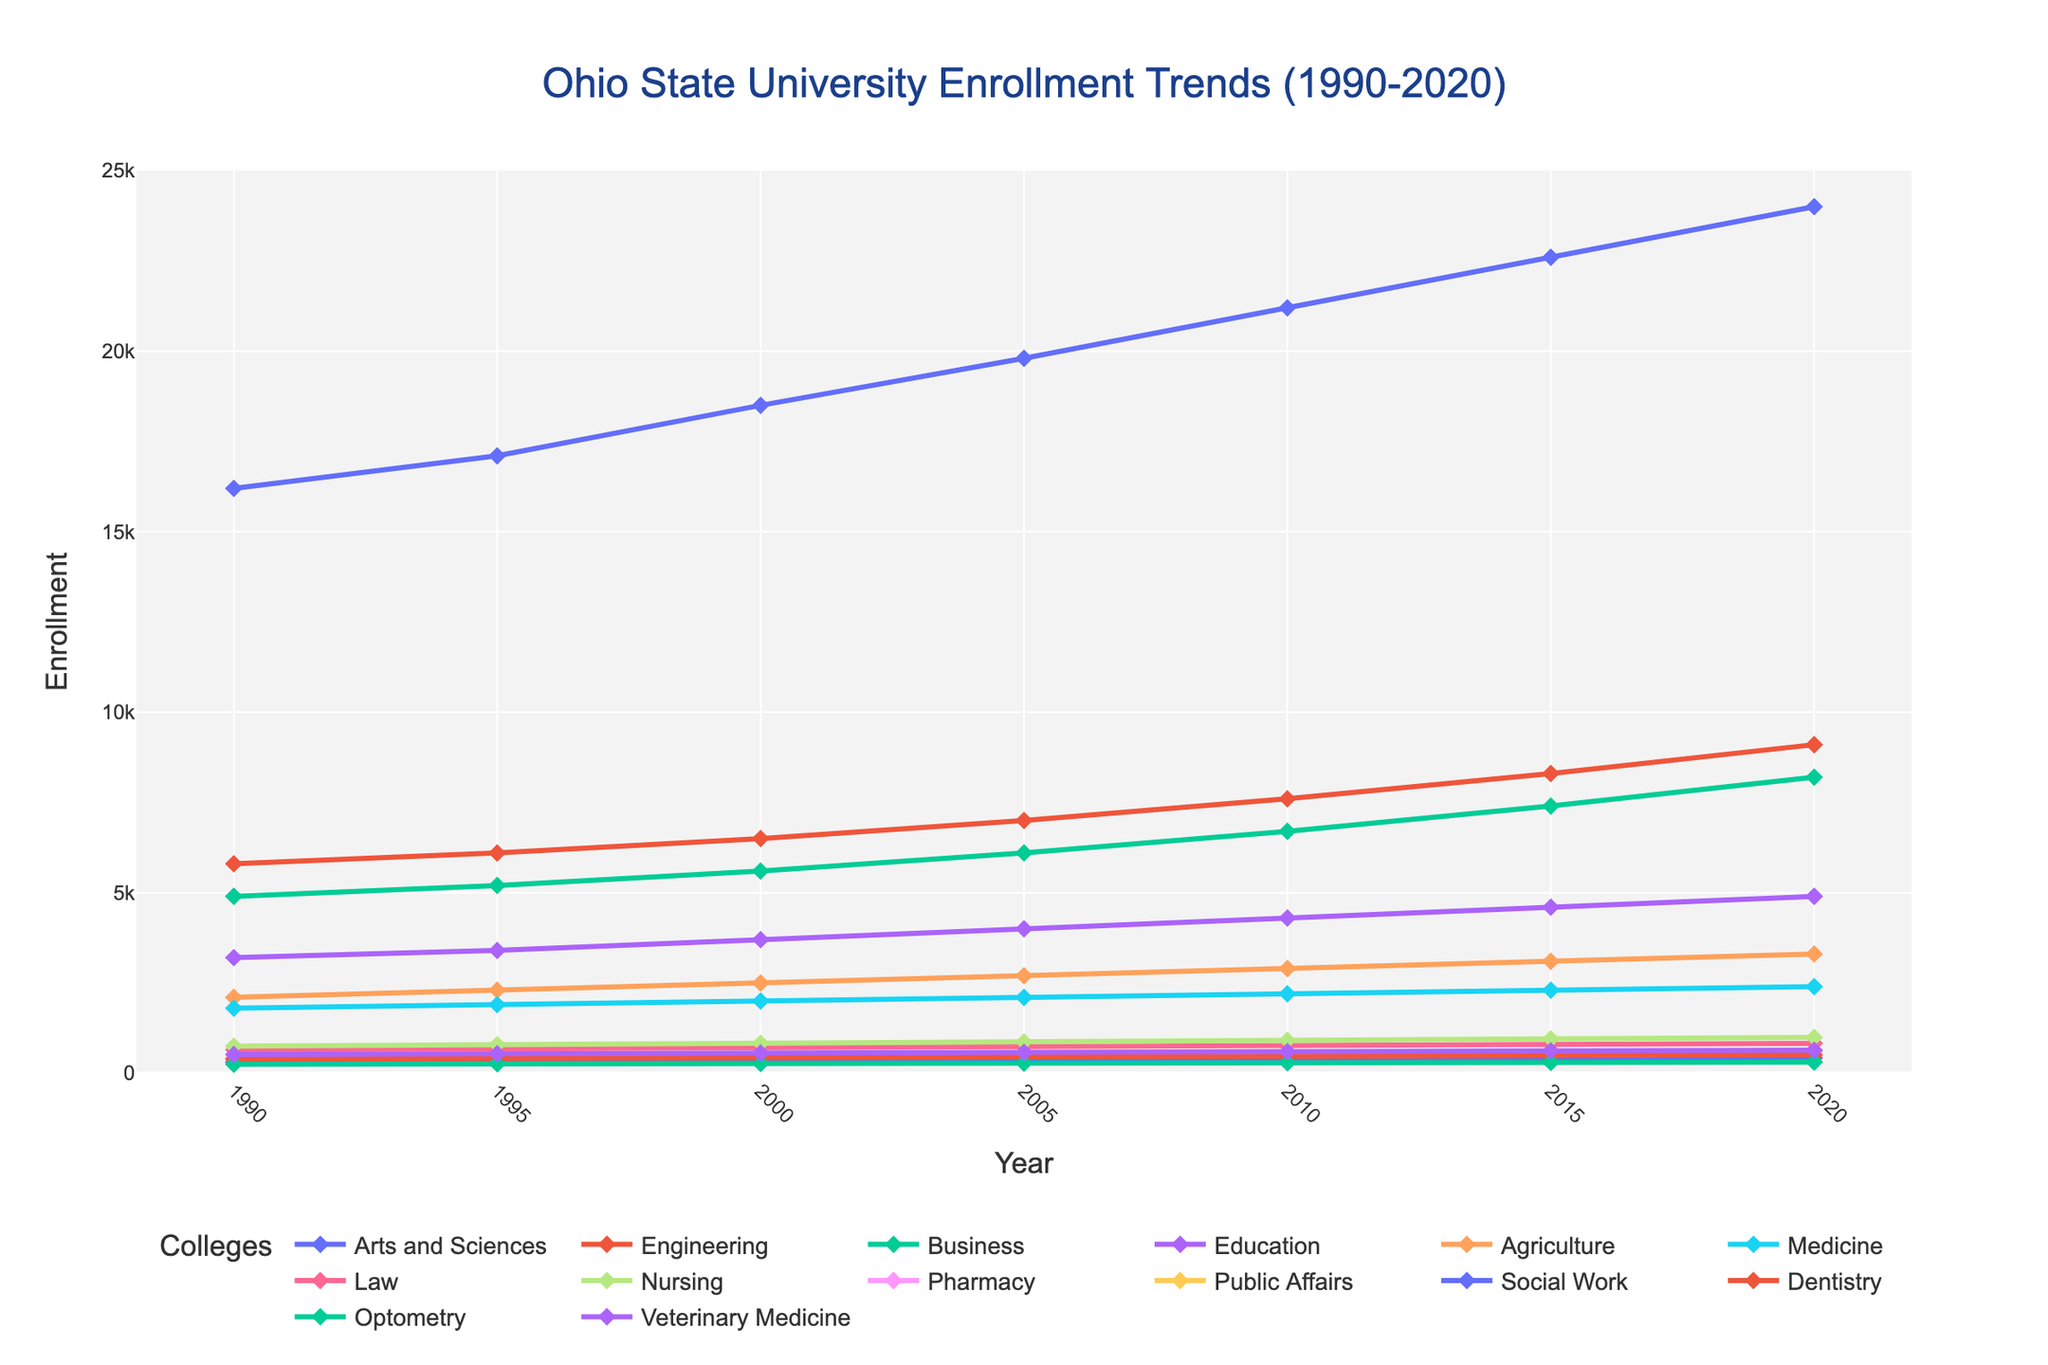What is the trend in enrollment for the College of Engineering from 1990 to 2020? The visual analysis of the plot indicates that the enrollment for the College of Engineering shows a steady upward trend from 1990 to 2020. The data points rise continuously each year.
Answer: Steady upward trend Which college had the highest enrollment in 2020? By visual inspection, the plot shows that the College of Arts and Sciences had the highest enrollment in 2020.
Answer: Arts and Sciences In 2000, how many students in total were enrolled in the Colleges of Business, Engineering, and Education? By summing the enrollment numbers for each college in 2000: Business (5600), Engineering (6500), and Education (3700), the total is 5600 + 6500 + 3700 = 15800.
Answer: 15800 Did any college experience a decline in enrollment during the period from 1990 to 2020? By examining the plot lines of each college, there are no visible declines in the enrollment trends for any colleges; all show either steady or increasing trends.
Answer: No Which college had the smallest enrollment in 1990, and what was the value? Observing the plot for the smallest data point in 1990, the College of Optometry had the smallest enrollment with a value of 250.
Answer: Optometry, 250 How much did the enrollment for the College of Nursing increase from 1990 to 2020? Enrollment in the College of Nursing increased from 750 in 1990 to 990 in 2020. The increase is calculated as 990 - 750 = 240.
Answer: 240 Between which years did the College of Medicine see the largest single increment in enrollment? By comparing the increments in the plot, the largest increment for the College of Medicine occurred between 1990 and 1995, from 1800 to 1900.
Answer: 1990 to 1995 What is the average enrollment for the College of Law from 1990 to 2020? Summing the enrollment numbers for the College of Law (650, 680, 710, 740, 770, 800, 830) and dividing by the number of years (7), the average is (650 + 680 + 710 + 740 + 770 + 800 + 830)/7 = 740.
Answer: 740 Which college had the highest enrollment growth rate from 1990 to 2020? By comparing the slopes of the enrollment lines, the College of Engineering shows the steepest slope, indicating the highest growth rate over the period.
Answer: Engineering Comparing the College of Education and the College of Business, which had a higher enrollment in 2010? In 2010, the enrollment for the College of Business was 6700 and for the College of Education was 4300, making the College of Business higher.
Answer: Business 